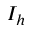<formula> <loc_0><loc_0><loc_500><loc_500>I _ { h }</formula> 